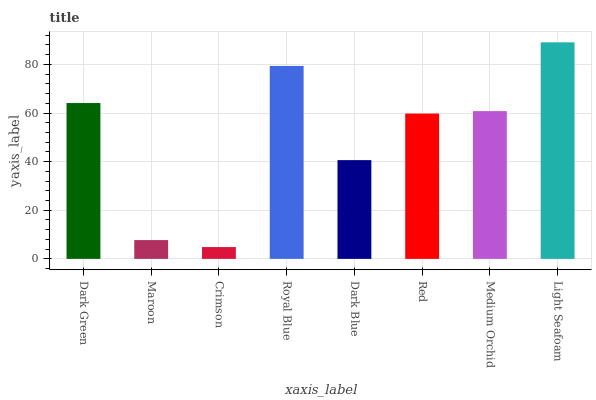Is Crimson the minimum?
Answer yes or no. Yes. Is Light Seafoam the maximum?
Answer yes or no. Yes. Is Maroon the minimum?
Answer yes or no. No. Is Maroon the maximum?
Answer yes or no. No. Is Dark Green greater than Maroon?
Answer yes or no. Yes. Is Maroon less than Dark Green?
Answer yes or no. Yes. Is Maroon greater than Dark Green?
Answer yes or no. No. Is Dark Green less than Maroon?
Answer yes or no. No. Is Medium Orchid the high median?
Answer yes or no. Yes. Is Red the low median?
Answer yes or no. Yes. Is Maroon the high median?
Answer yes or no. No. Is Dark Green the low median?
Answer yes or no. No. 